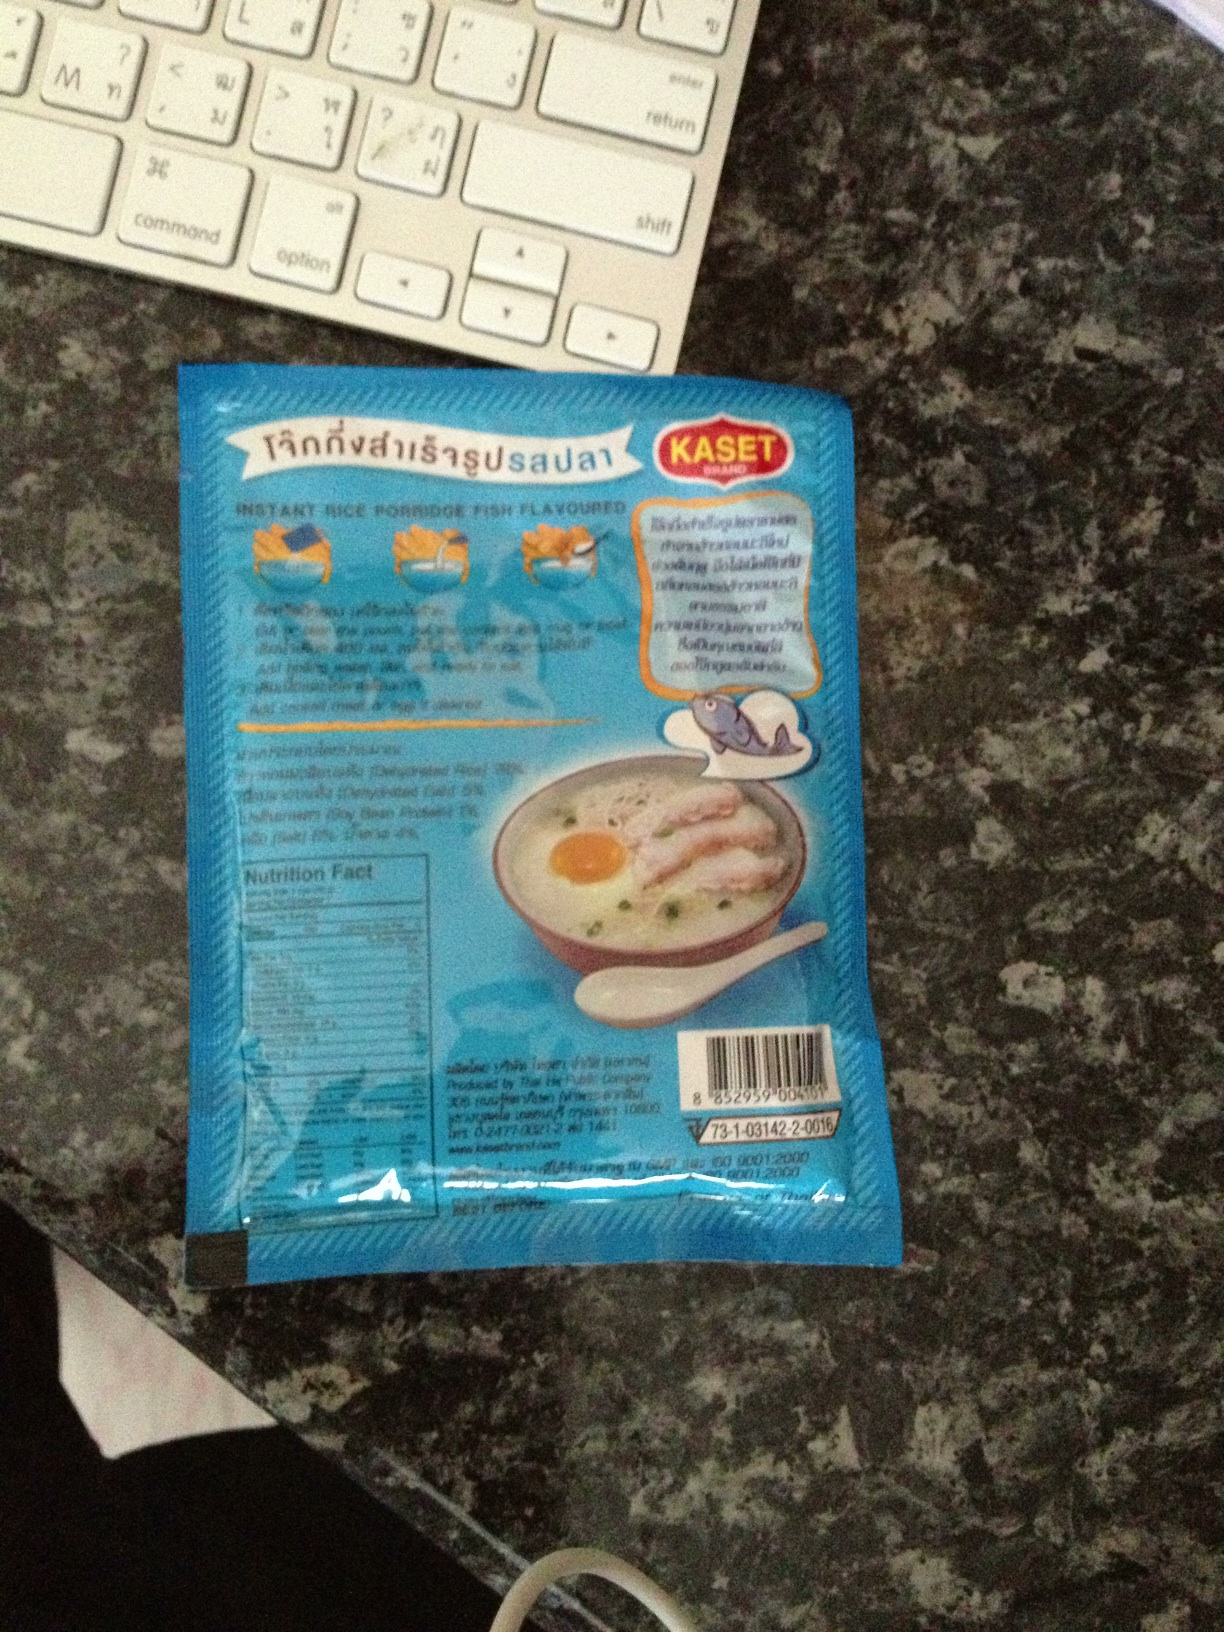Is this a product from a specific country? Yes, the language and design on the packaging suggest that this product is from Thailand. The script on the package is in Thai, which is indicative of the product's origin. 